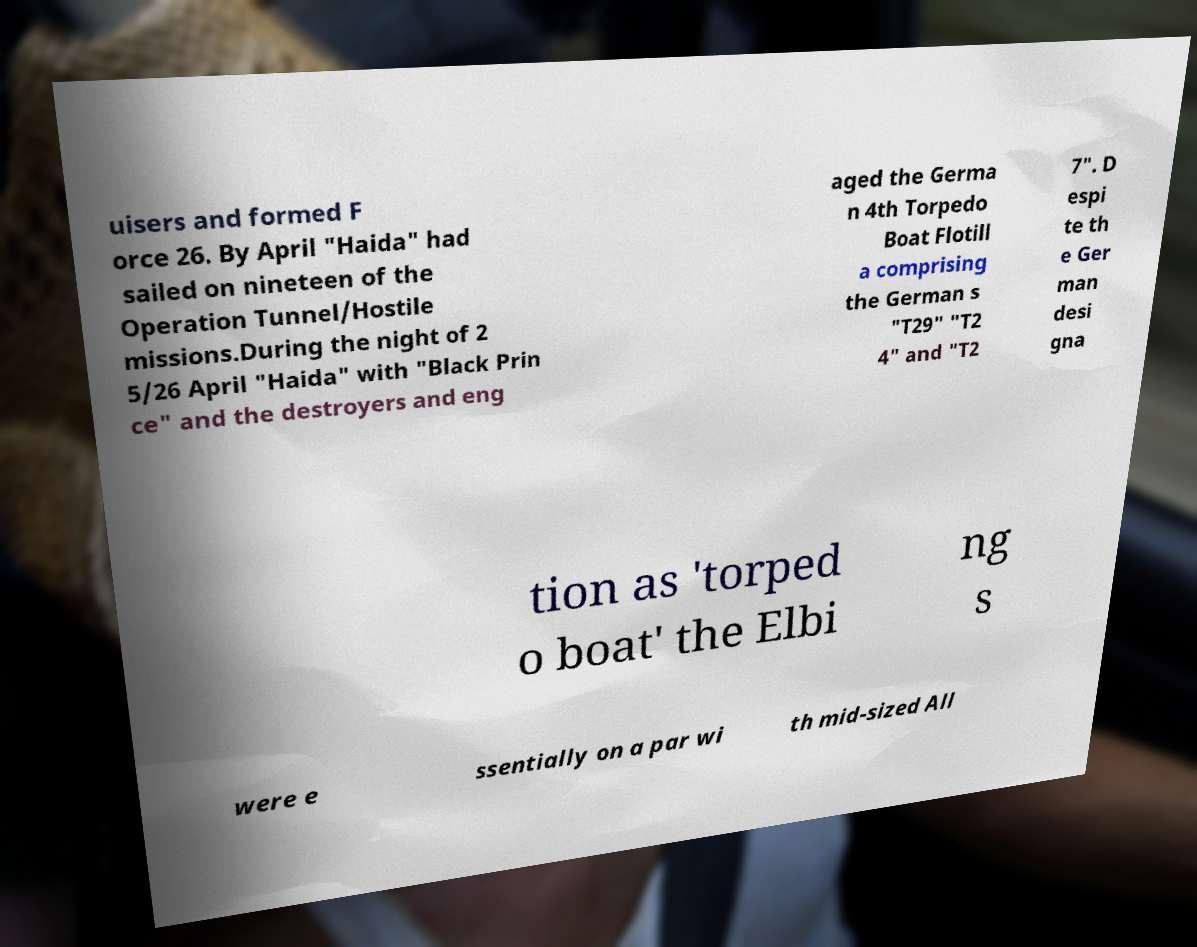Could you extract and type out the text from this image? uisers and formed F orce 26. By April "Haida" had sailed on nineteen of the Operation Tunnel/Hostile missions.During the night of 2 5/26 April "Haida" with "Black Prin ce" and the destroyers and eng aged the Germa n 4th Torpedo Boat Flotill a comprising the German s "T29" "T2 4" and "T2 7". D espi te th e Ger man desi gna tion as 'torped o boat' the Elbi ng s were e ssentially on a par wi th mid-sized All 